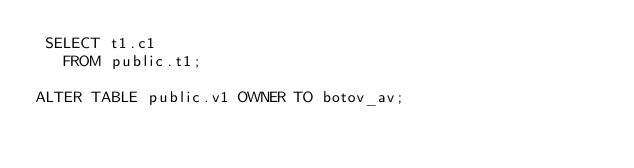<code> <loc_0><loc_0><loc_500><loc_500><_SQL_> SELECT t1.c1
   FROM public.t1;

ALTER TABLE public.v1 OWNER TO botov_av;</code> 